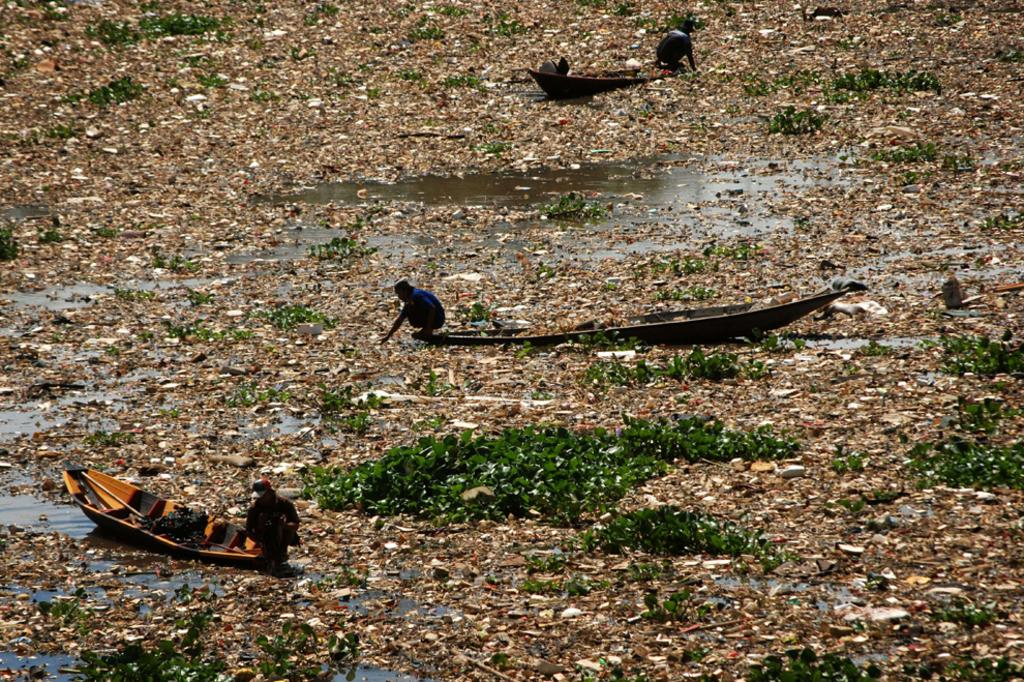What are the people in the image doing? The people in the image are in boats. What else can be seen in the image besides the boats? There is garbage, water, and plants visible in the image. How many brothers are visible in the image? There is no mention of a brother or any people besides those in the boats in the image. 